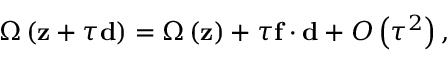<formula> <loc_0><loc_0><loc_500><loc_500>\Omega \left ( z + \tau d \right ) = \Omega \left ( z \right ) + \tau f \cdot d + O \left ( \tau ^ { 2 } \right ) ,</formula> 